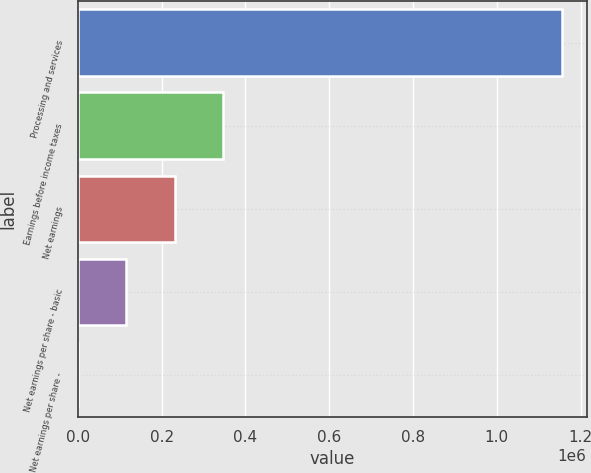<chart> <loc_0><loc_0><loc_500><loc_500><bar_chart><fcel>Processing and services<fcel>Earnings before income taxes<fcel>Net earnings<fcel>Net earnings per share - basic<fcel>Net earnings per share -<nl><fcel>1.15651e+06<fcel>346953<fcel>231302<fcel>115651<fcel>0.75<nl></chart> 